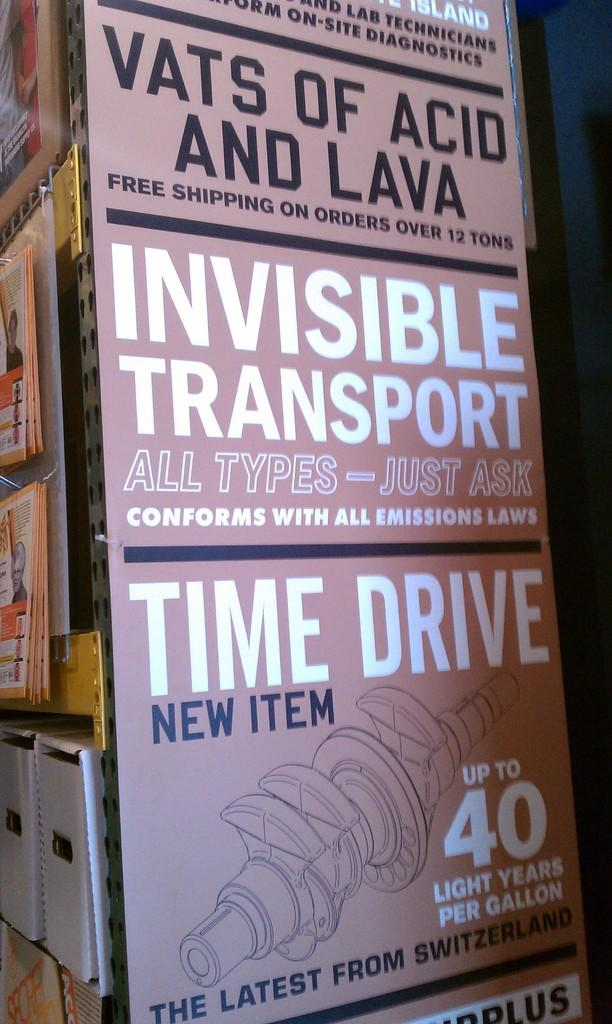<image>
Share a concise interpretation of the image provided. A new product from Switzerland called the Time Drive is apparently good for 40 light years per gallon. 